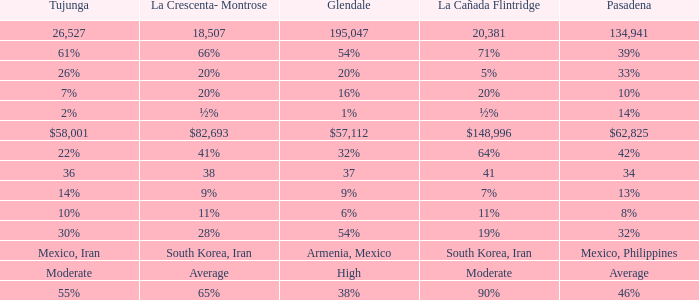When La Crescenta-Montrose has 66%, what is Tujunga? 61%. 